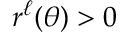<formula> <loc_0><loc_0><loc_500><loc_500>r ^ { \ell } ( \theta ) > 0</formula> 